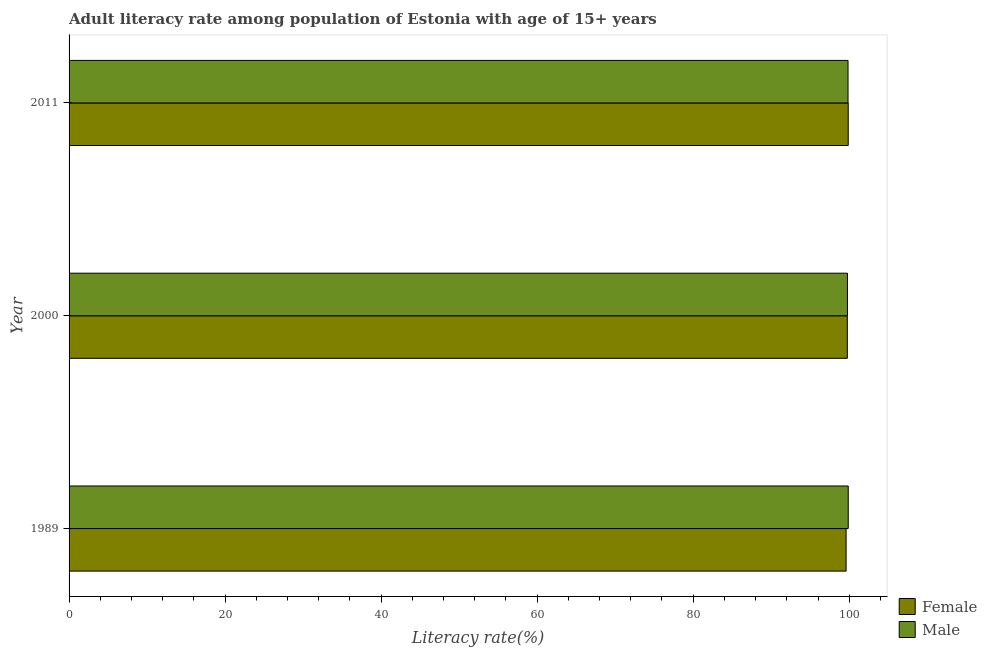Are the number of bars per tick equal to the number of legend labels?
Provide a succinct answer. Yes. How many bars are there on the 2nd tick from the top?
Ensure brevity in your answer.  2. How many bars are there on the 3rd tick from the bottom?
Provide a short and direct response. 2. What is the male adult literacy rate in 2011?
Make the answer very short. 99.85. Across all years, what is the maximum female adult literacy rate?
Make the answer very short. 99.87. Across all years, what is the minimum male adult literacy rate?
Your answer should be very brief. 99.78. In which year was the male adult literacy rate maximum?
Give a very brief answer. 1989. In which year was the male adult literacy rate minimum?
Offer a very short reply. 2000. What is the total female adult literacy rate in the graph?
Your answer should be very brief. 299.24. What is the difference between the female adult literacy rate in 1989 and that in 2000?
Offer a terse response. -0.16. What is the difference between the male adult literacy rate in 1989 and the female adult literacy rate in 2000?
Ensure brevity in your answer.  0.12. What is the average female adult literacy rate per year?
Keep it short and to the point. 99.75. In the year 2000, what is the difference between the female adult literacy rate and male adult literacy rate?
Your answer should be compact. -0.02. In how many years, is the female adult literacy rate greater than 24 %?
Give a very brief answer. 3. Is the female adult literacy rate in 1989 less than that in 2011?
Give a very brief answer. Yes. What is the difference between the highest and the second highest female adult literacy rate?
Your response must be concise. 0.11. What is the difference between the highest and the lowest female adult literacy rate?
Offer a very short reply. 0.27. In how many years, is the male adult literacy rate greater than the average male adult literacy rate taken over all years?
Your answer should be very brief. 2. What is the difference between two consecutive major ticks on the X-axis?
Your answer should be compact. 20. Does the graph contain grids?
Give a very brief answer. No. Where does the legend appear in the graph?
Offer a terse response. Bottom right. What is the title of the graph?
Offer a very short reply. Adult literacy rate among population of Estonia with age of 15+ years. Does "Secondary Education" appear as one of the legend labels in the graph?
Ensure brevity in your answer.  No. What is the label or title of the X-axis?
Provide a short and direct response. Literacy rate(%). What is the label or title of the Y-axis?
Provide a short and direct response. Year. What is the Literacy rate(%) of Female in 1989?
Your response must be concise. 99.6. What is the Literacy rate(%) in Male in 1989?
Give a very brief answer. 99.88. What is the Literacy rate(%) in Female in 2000?
Provide a short and direct response. 99.76. What is the Literacy rate(%) in Male in 2000?
Provide a succinct answer. 99.78. What is the Literacy rate(%) of Female in 2011?
Your answer should be very brief. 99.87. What is the Literacy rate(%) in Male in 2011?
Make the answer very short. 99.85. Across all years, what is the maximum Literacy rate(%) of Female?
Your answer should be compact. 99.87. Across all years, what is the maximum Literacy rate(%) of Male?
Your response must be concise. 99.88. Across all years, what is the minimum Literacy rate(%) in Female?
Provide a short and direct response. 99.6. Across all years, what is the minimum Literacy rate(%) of Male?
Your answer should be compact. 99.78. What is the total Literacy rate(%) in Female in the graph?
Your response must be concise. 299.24. What is the total Literacy rate(%) in Male in the graph?
Give a very brief answer. 299.5. What is the difference between the Literacy rate(%) of Female in 1989 and that in 2000?
Offer a very short reply. -0.16. What is the difference between the Literacy rate(%) of Male in 1989 and that in 2000?
Ensure brevity in your answer.  0.1. What is the difference between the Literacy rate(%) in Female in 1989 and that in 2011?
Offer a very short reply. -0.27. What is the difference between the Literacy rate(%) in Male in 1989 and that in 2011?
Make the answer very short. 0.03. What is the difference between the Literacy rate(%) in Female in 2000 and that in 2011?
Make the answer very short. -0.11. What is the difference between the Literacy rate(%) of Male in 2000 and that in 2011?
Offer a terse response. -0.07. What is the difference between the Literacy rate(%) of Female in 1989 and the Literacy rate(%) of Male in 2000?
Provide a short and direct response. -0.17. What is the difference between the Literacy rate(%) of Female in 1989 and the Literacy rate(%) of Male in 2011?
Offer a very short reply. -0.25. What is the difference between the Literacy rate(%) in Female in 2000 and the Literacy rate(%) in Male in 2011?
Offer a terse response. -0.09. What is the average Literacy rate(%) of Female per year?
Ensure brevity in your answer.  99.75. What is the average Literacy rate(%) of Male per year?
Keep it short and to the point. 99.83. In the year 1989, what is the difference between the Literacy rate(%) in Female and Literacy rate(%) in Male?
Your response must be concise. -0.27. In the year 2000, what is the difference between the Literacy rate(%) of Female and Literacy rate(%) of Male?
Your answer should be very brief. -0.02. In the year 2011, what is the difference between the Literacy rate(%) in Female and Literacy rate(%) in Male?
Make the answer very short. 0.02. What is the ratio of the Literacy rate(%) in Male in 1989 to that in 2000?
Your response must be concise. 1. What is the ratio of the Literacy rate(%) of Female in 1989 to that in 2011?
Ensure brevity in your answer.  1. What is the ratio of the Literacy rate(%) in Male in 1989 to that in 2011?
Your response must be concise. 1. What is the ratio of the Literacy rate(%) in Female in 2000 to that in 2011?
Offer a very short reply. 1. What is the ratio of the Literacy rate(%) of Male in 2000 to that in 2011?
Give a very brief answer. 1. What is the difference between the highest and the second highest Literacy rate(%) of Female?
Give a very brief answer. 0.11. What is the difference between the highest and the second highest Literacy rate(%) in Male?
Give a very brief answer. 0.03. What is the difference between the highest and the lowest Literacy rate(%) of Female?
Provide a succinct answer. 0.27. What is the difference between the highest and the lowest Literacy rate(%) of Male?
Give a very brief answer. 0.1. 